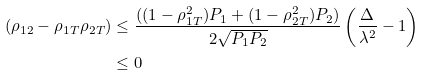Convert formula to latex. <formula><loc_0><loc_0><loc_500><loc_500>( \rho _ { 1 2 } - \rho _ { 1 T } \rho _ { 2 T } ) & \leq \frac { ( ( 1 - \rho _ { 1 T } ^ { 2 } ) P _ { 1 } + ( 1 - \rho _ { 2 T } ^ { 2 } ) P _ { 2 } ) } { 2 \sqrt { P _ { 1 } P _ { 2 } } } \left ( \frac { \Delta } { \lambda ^ { 2 } } - 1 \right ) \\ & \leq 0</formula> 